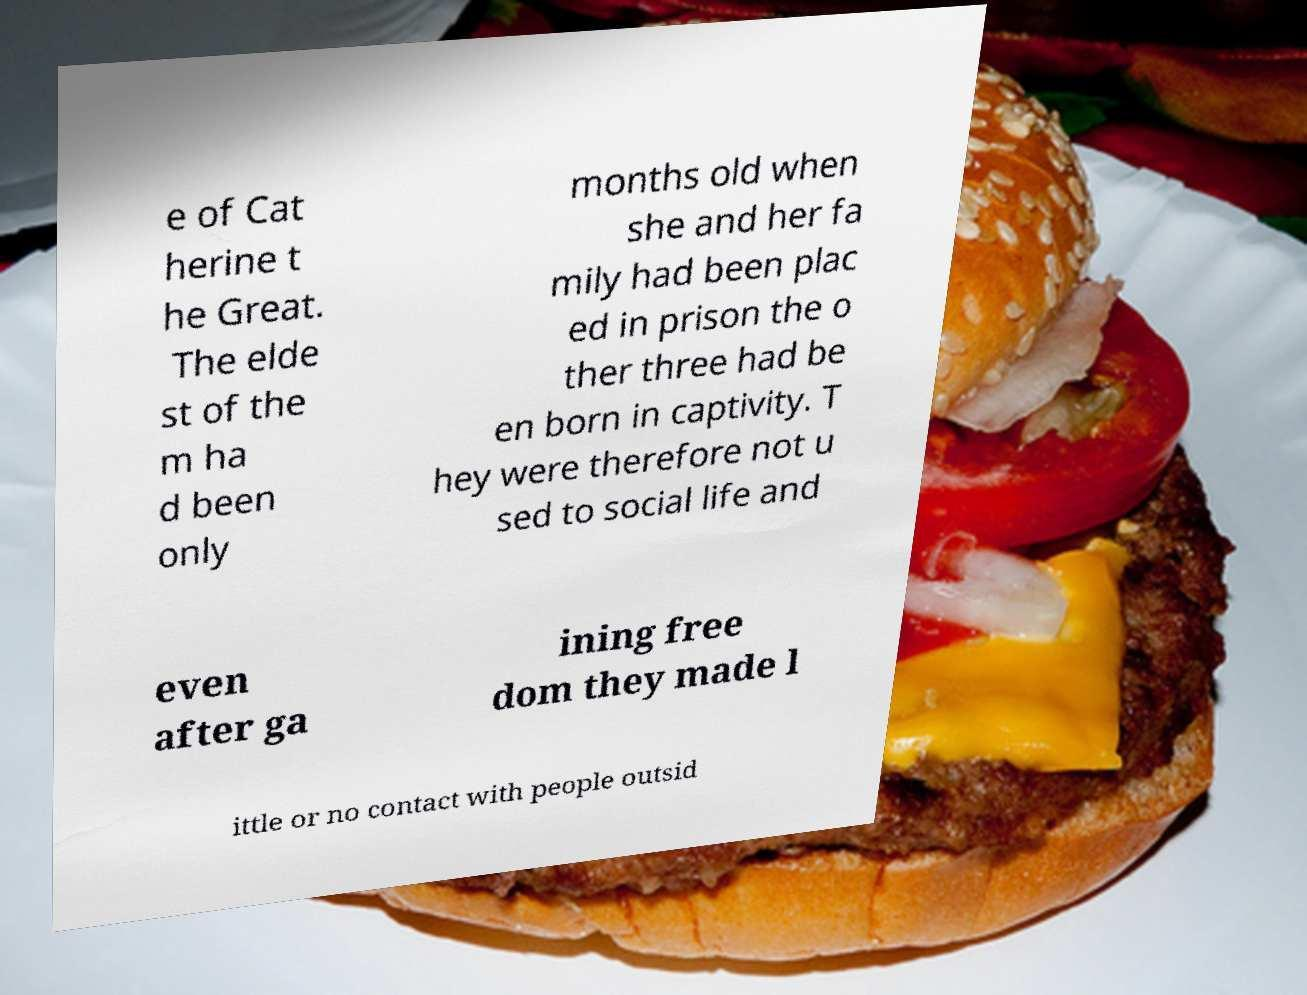What messages or text are displayed in this image? I need them in a readable, typed format. e of Cat herine t he Great. The elde st of the m ha d been only months old when she and her fa mily had been plac ed in prison the o ther three had be en born in captivity. T hey were therefore not u sed to social life and even after ga ining free dom they made l ittle or no contact with people outsid 